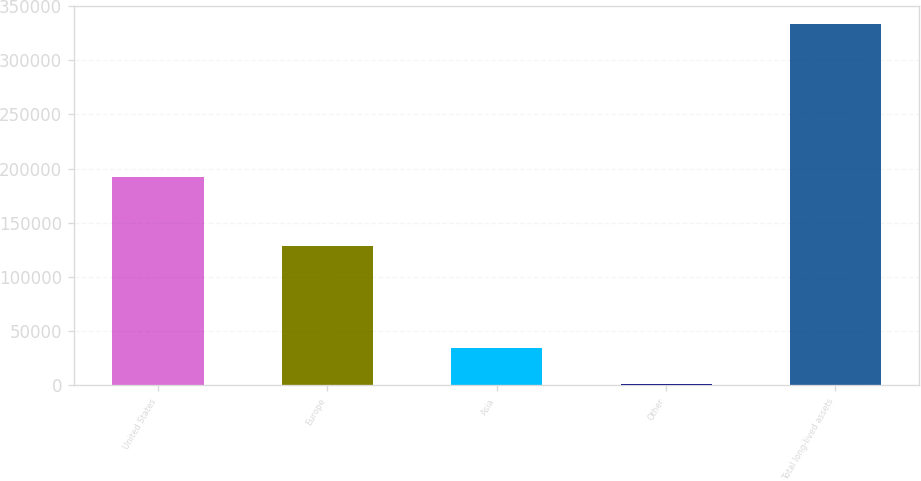Convert chart to OTSL. <chart><loc_0><loc_0><loc_500><loc_500><bar_chart><fcel>United States<fcel>Europe<fcel>Asia<fcel>Other<fcel>Total long-lived assets<nl><fcel>192352<fcel>128189<fcel>34186.9<fcel>946<fcel>333355<nl></chart> 